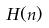<formula> <loc_0><loc_0><loc_500><loc_500>H ( n )</formula> 